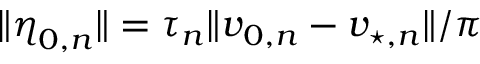<formula> <loc_0><loc_0><loc_500><loc_500>\| \eta _ { 0 , n } \| = \tau _ { n } \| v _ { 0 , n } - v _ { \, ^ { * } , n } \| / \pi</formula> 